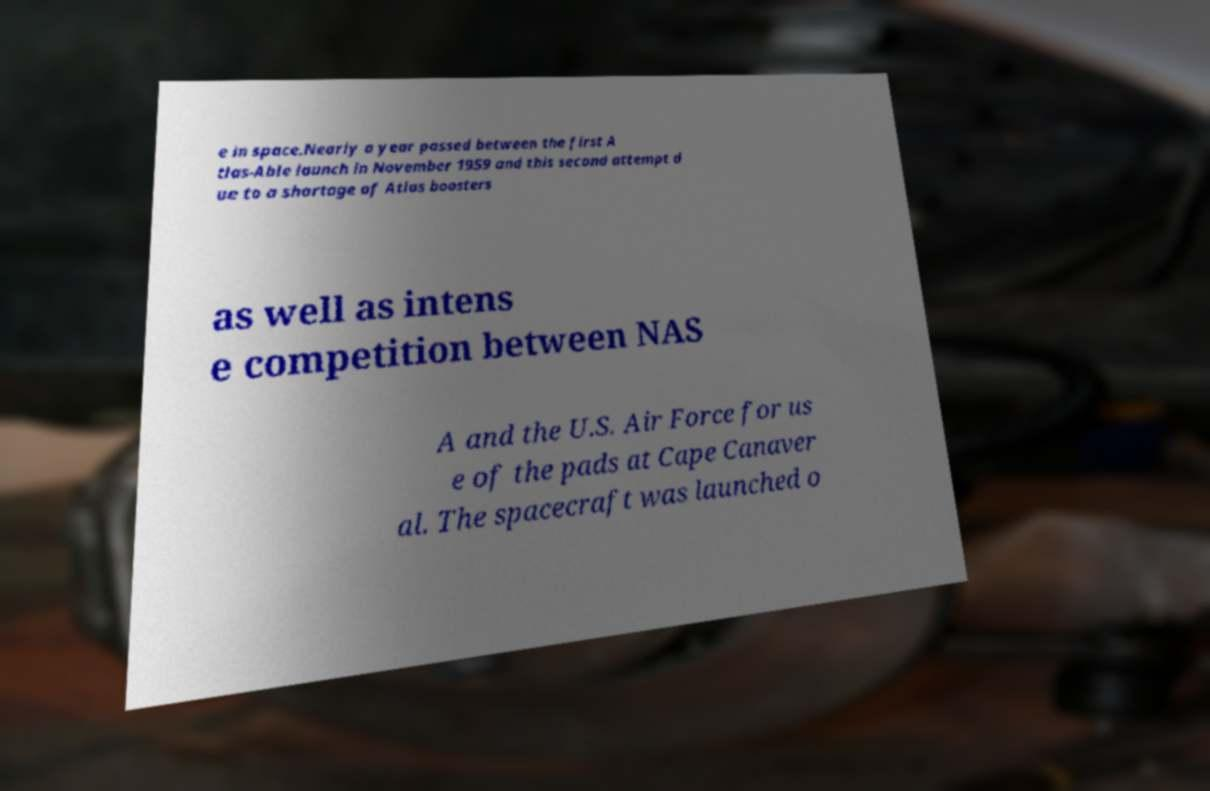For documentation purposes, I need the text within this image transcribed. Could you provide that? e in space.Nearly a year passed between the first A tlas-Able launch in November 1959 and this second attempt d ue to a shortage of Atlas boosters as well as intens e competition between NAS A and the U.S. Air Force for us e of the pads at Cape Canaver al. The spacecraft was launched o 